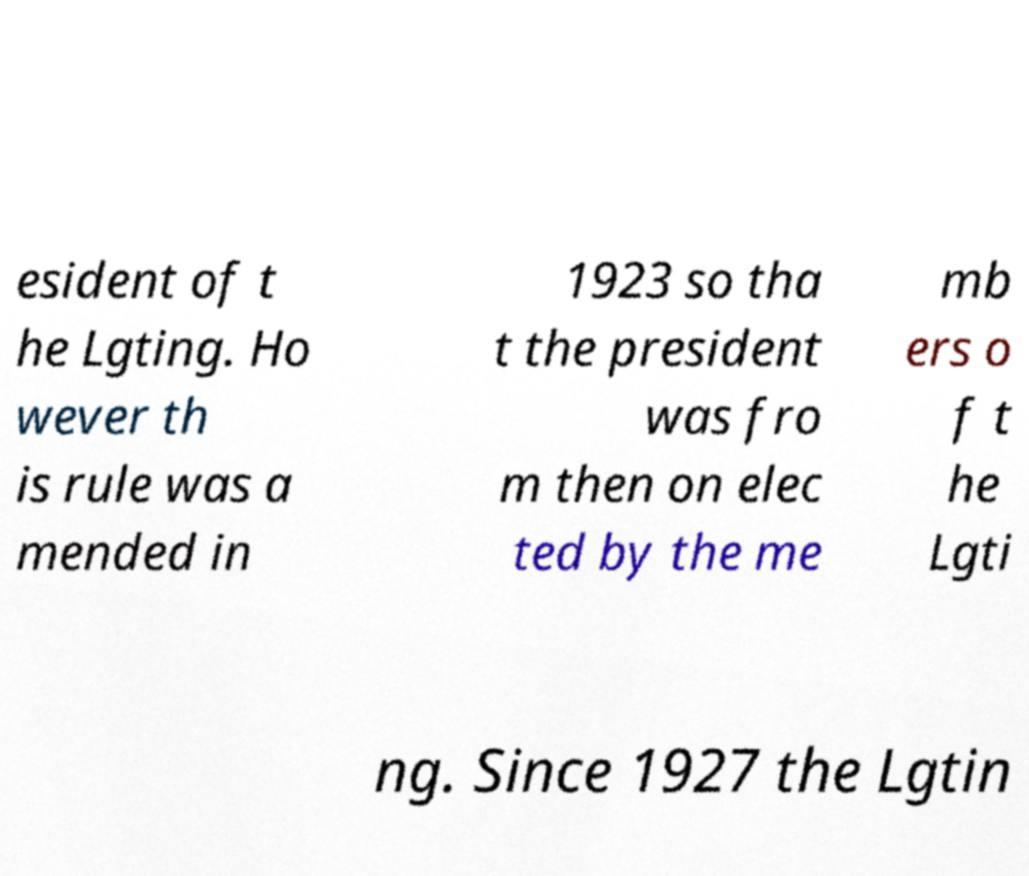Please identify and transcribe the text found in this image. esident of t he Lgting. Ho wever th is rule was a mended in 1923 so tha t the president was fro m then on elec ted by the me mb ers o f t he Lgti ng. Since 1927 the Lgtin 